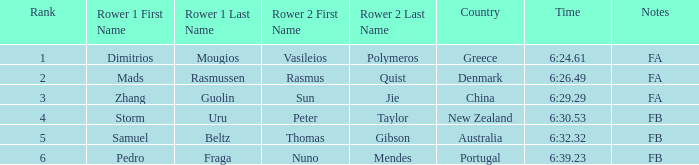What is the rank of the time of 6:30.53? 1.0. 